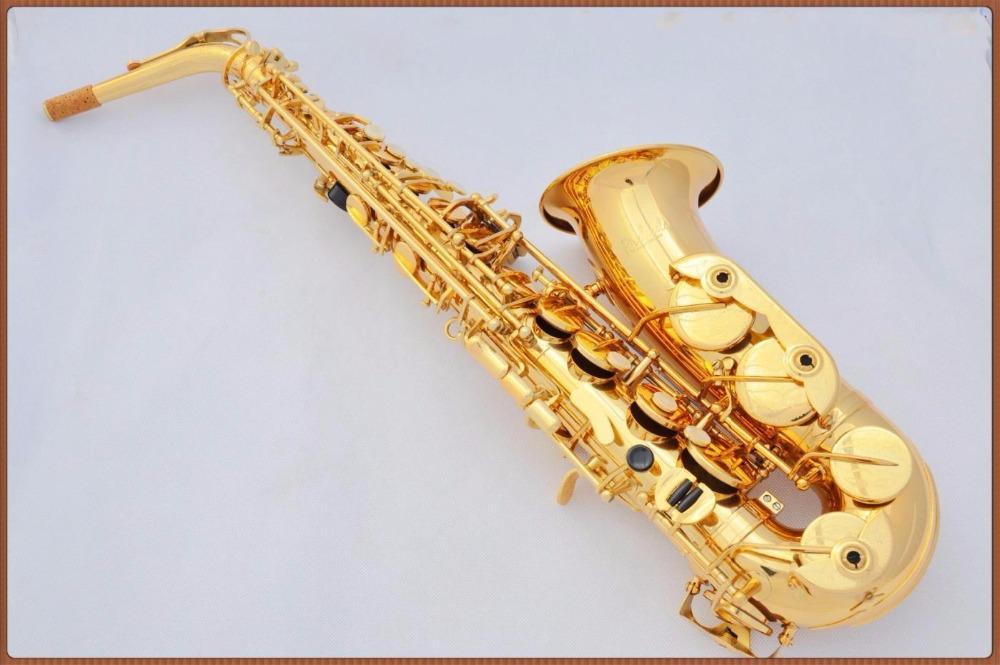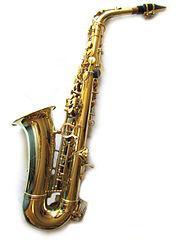The first image is the image on the left, the second image is the image on the right. Evaluate the accuracy of this statement regarding the images: "Each image contains one saxophone displayed with its bell facing rightward and its mouthpiece pointing leftward, and each saxophone has a curved bell end.". Is it true? Answer yes or no. No. The first image is the image on the left, the second image is the image on the right. Assess this claim about the two images: "There are exactly two saxophones with their mouthpiece pointing to the left.". Correct or not? Answer yes or no. No. 